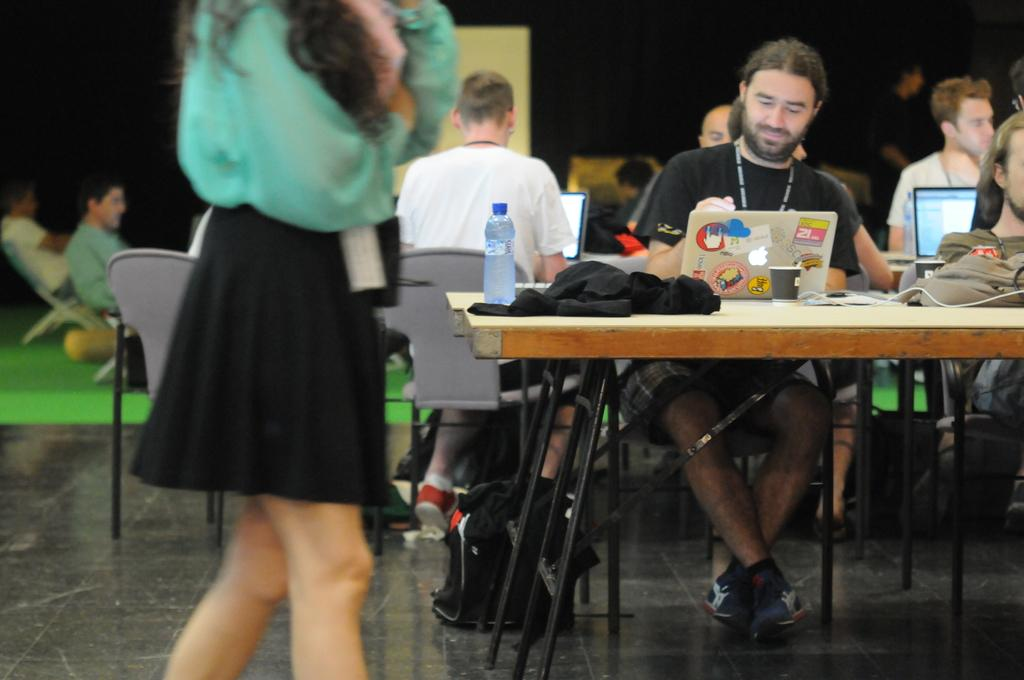How many people are in the image? There is a group of people in the image. What objects are on the table in the image? There are laptops, cups, a bottle, and clothes on the table in the image. What type of furniture is present in the image? There is a table in the image. What is located at the bottom of the image? There is a bag at the bottom of the image. What is on the floor in the image? There is a mat in the image. What type of behavior can be observed from the balloon in the image? There is no balloon present in the image, so no behavior can be observed. 